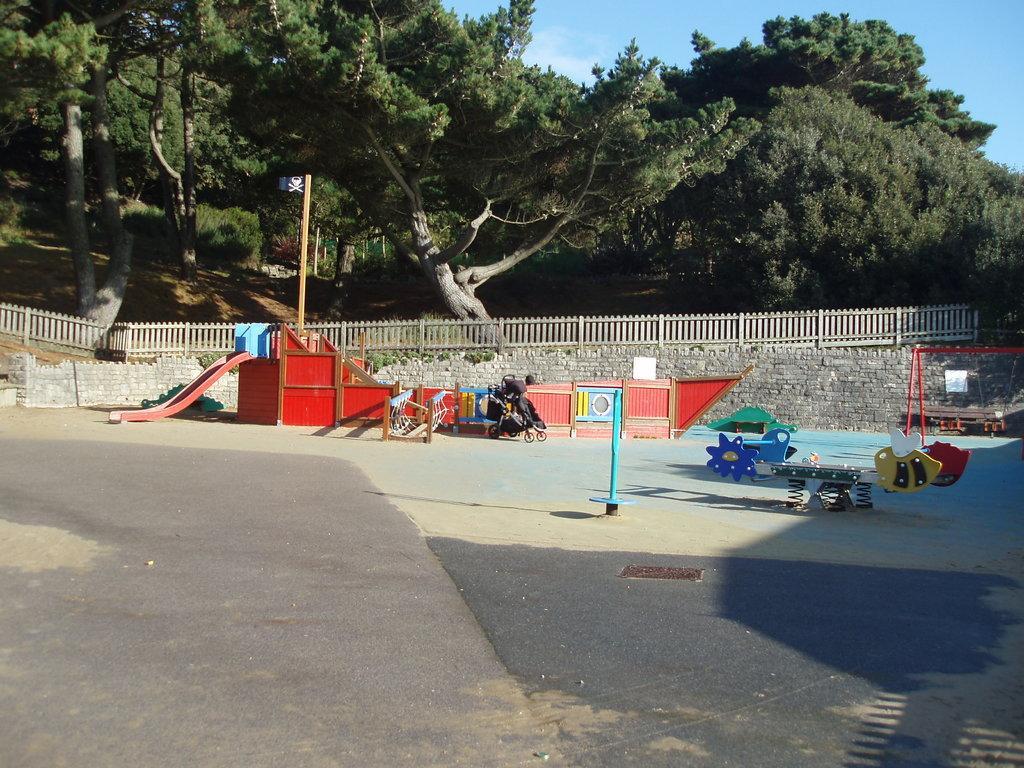How would you summarize this image in a sentence or two? In this image we can see a baby carrier placed on the ground. To the left side of the image we can see a slide, a flag on a pole. To the right side, we can see several toys, group of poles. In the background, we can see a wooden fence, a group of trees and the sky. 